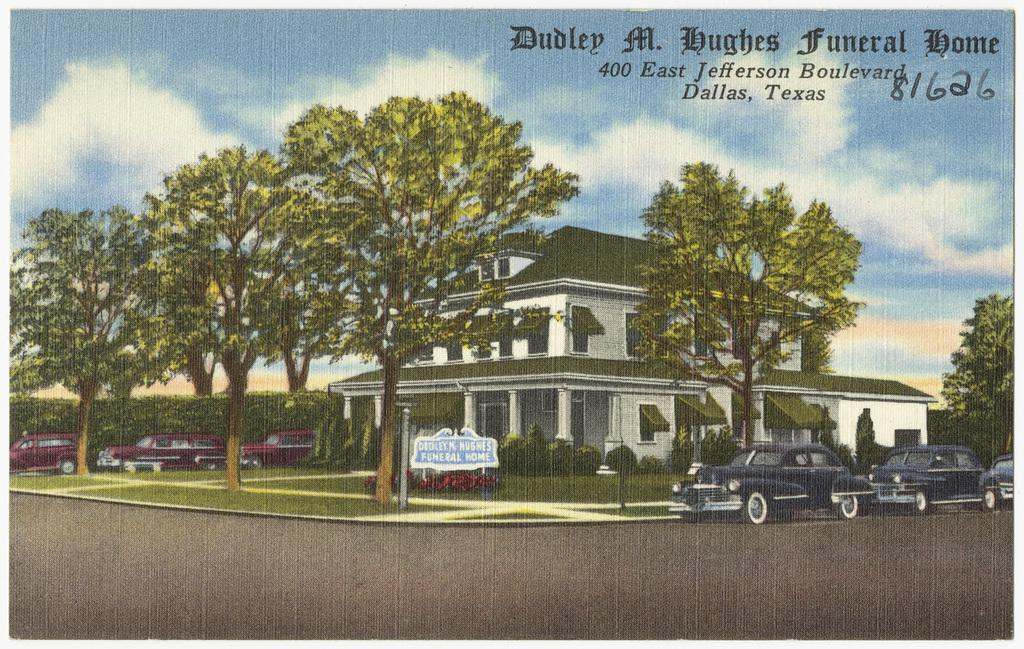What type of image is being described? The image is graphical in nature. What can be seen in the image besides the graphical elements? There are vehicles, trees, plants, buildings, clouds, and the sky visible in the image. What type of ring is being worn by the tree in the image? There is no ring present in the image, as it features a graphical representation of various elements, including trees. 